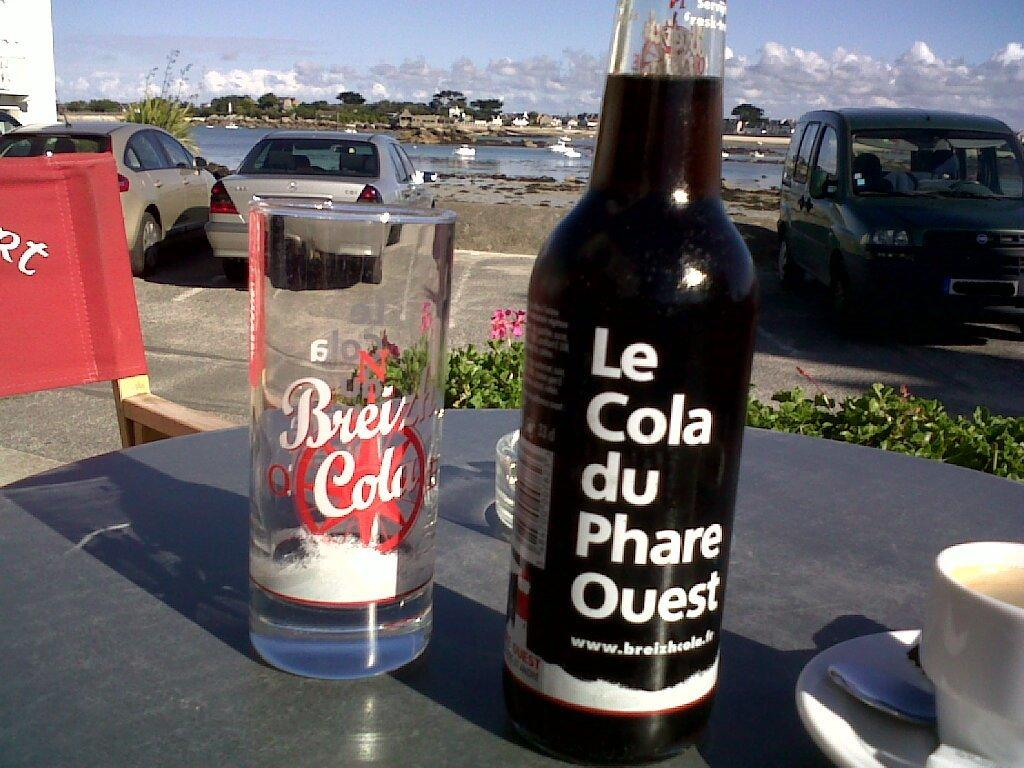What is on the table in the image? There is a wine bottle and a glass on the table. Can you describe the vehicles in the background? There are three cars parked in a parking space in the background. What is visible in the sky in the image? The sky is visible in the background, and clouds are present. How many hats are on the table in the image? There are no hats present on the table in the image. What type of lumber is being used to construct the cars in the background? The image does not show any construction of the cars, and there is no mention of lumber. 